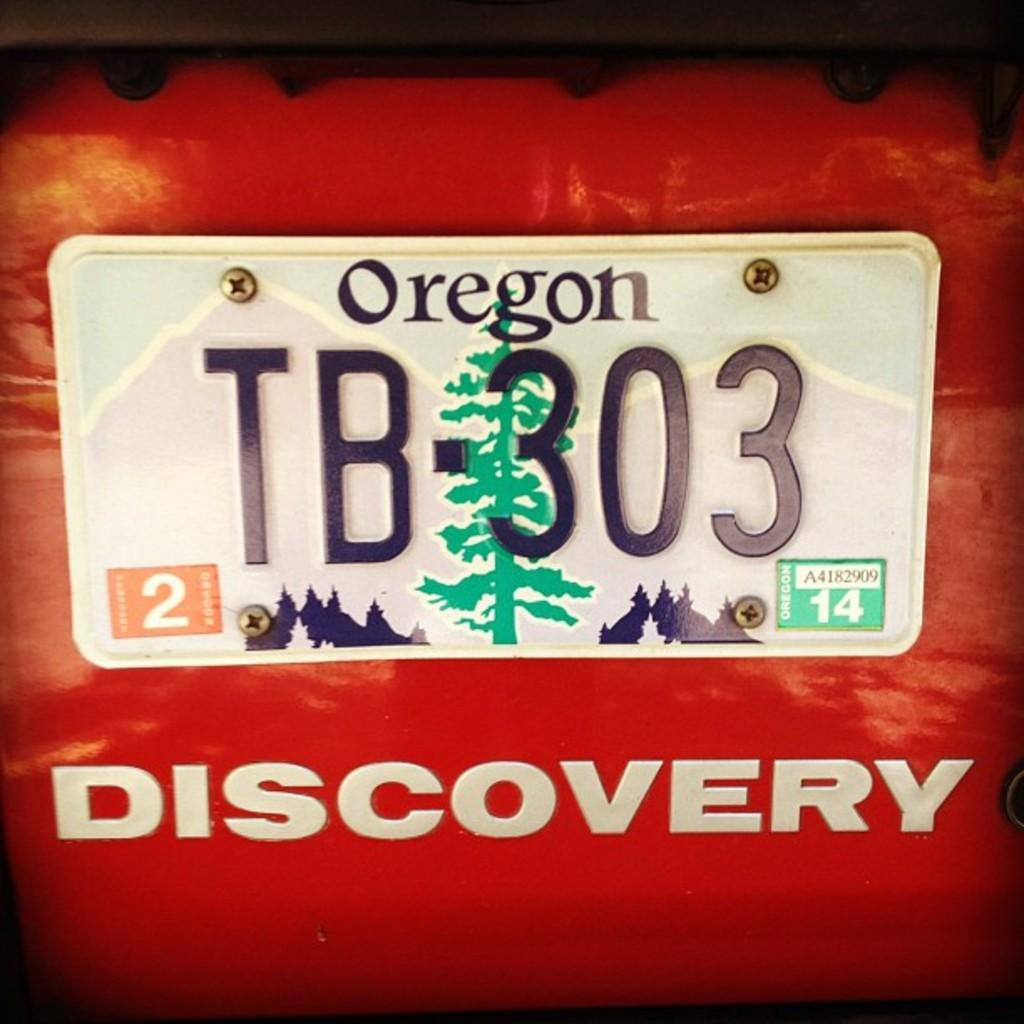<image>
Give a short and clear explanation of the subsequent image. A license plate on a red Discovery shows that the vehicle is from Oregon. 